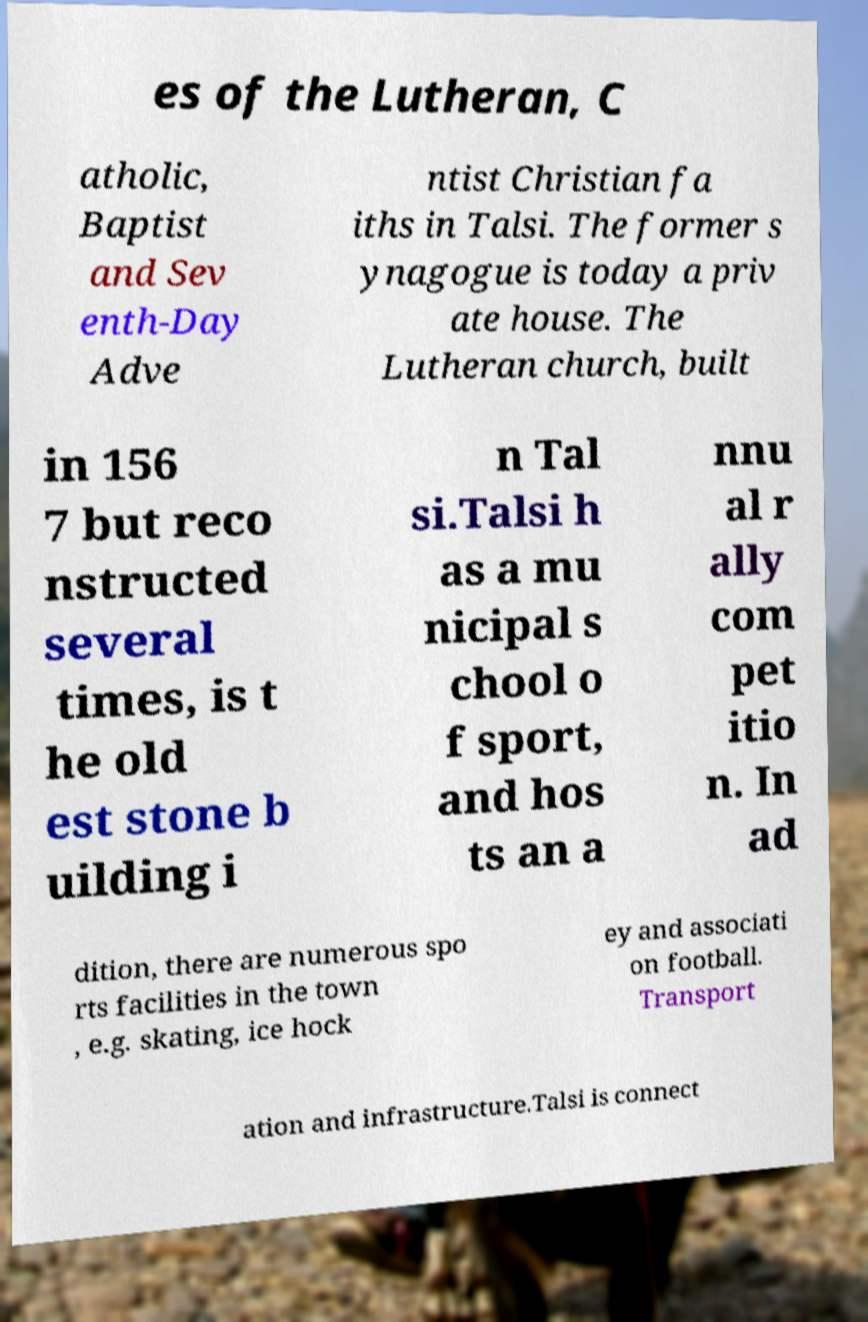Can you accurately transcribe the text from the provided image for me? es of the Lutheran, C atholic, Baptist and Sev enth-Day Adve ntist Christian fa iths in Talsi. The former s ynagogue is today a priv ate house. The Lutheran church, built in 156 7 but reco nstructed several times, is t he old est stone b uilding i n Tal si.Talsi h as a mu nicipal s chool o f sport, and hos ts an a nnu al r ally com pet itio n. In ad dition, there are numerous spo rts facilities in the town , e.g. skating, ice hock ey and associati on football. Transport ation and infrastructure.Talsi is connect 